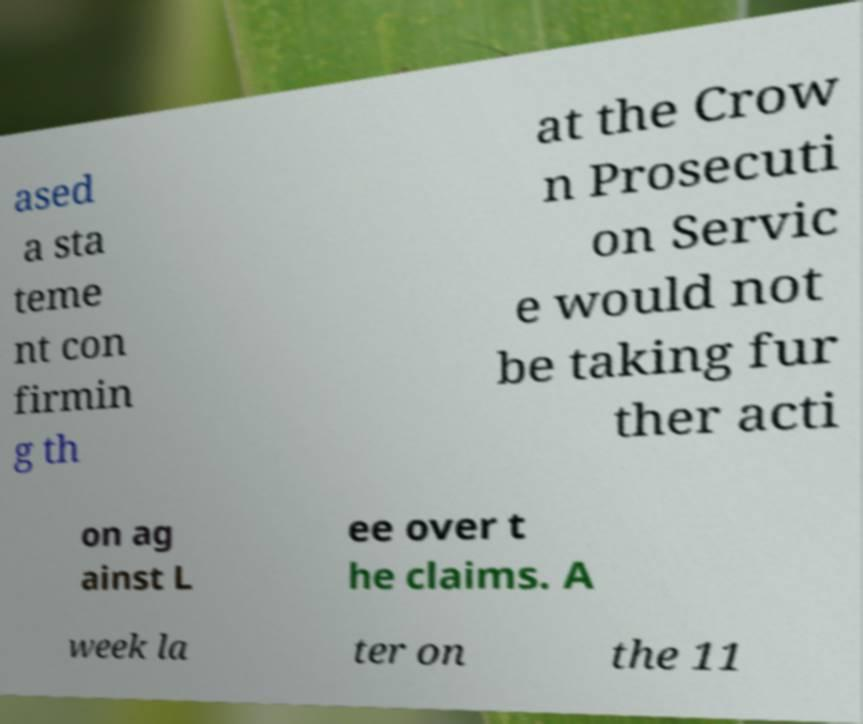Please identify and transcribe the text found in this image. ased a sta teme nt con firmin g th at the Crow n Prosecuti on Servic e would not be taking fur ther acti on ag ainst L ee over t he claims. A week la ter on the 11 